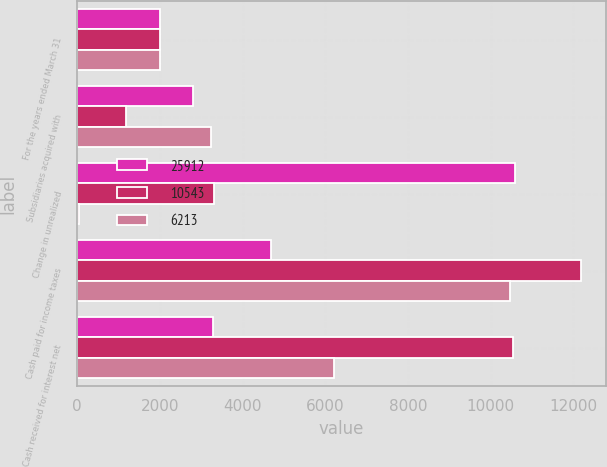Convert chart. <chart><loc_0><loc_0><loc_500><loc_500><stacked_bar_chart><ecel><fcel>For the years ended March 31<fcel>Subsidiaries acquired with<fcel>Change in unrealized<fcel>Cash paid for income taxes<fcel>Cash received for interest net<nl><fcel>25912<fcel>2006<fcel>2793<fcel>10576<fcel>4698<fcel>3281.5<nl><fcel>10543<fcel>2005<fcel>1191<fcel>3317<fcel>12178<fcel>10543<nl><fcel>6213<fcel>2004<fcel>3246<fcel>37<fcel>10463<fcel>6213<nl></chart> 